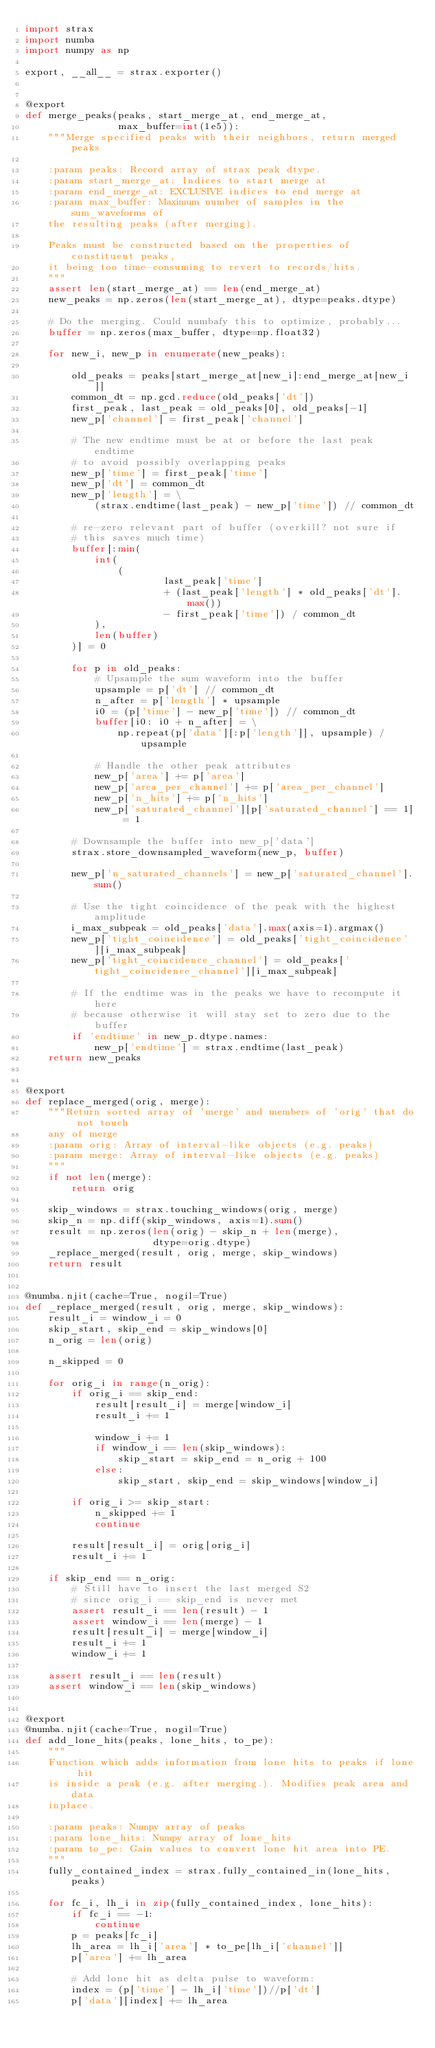Convert code to text. <code><loc_0><loc_0><loc_500><loc_500><_Python_>import strax
import numba
import numpy as np

export, __all__ = strax.exporter()


@export
def merge_peaks(peaks, start_merge_at, end_merge_at,
                max_buffer=int(1e5)):
    """Merge specified peaks with their neighbors, return merged peaks

    :param peaks: Record array of strax peak dtype.
    :param start_merge_at: Indices to start merge at
    :param end_merge_at: EXCLUSIVE indices to end merge at
    :param max_buffer: Maximum number of samples in the sum_waveforms of
    the resulting peaks (after merging).

    Peaks must be constructed based on the properties of constituent peaks,
    it being too time-consuming to revert to records/hits.
    """
    assert len(start_merge_at) == len(end_merge_at)
    new_peaks = np.zeros(len(start_merge_at), dtype=peaks.dtype)

    # Do the merging. Could numbafy this to optimize, probably...
    buffer = np.zeros(max_buffer, dtype=np.float32)

    for new_i, new_p in enumerate(new_peaks):

        old_peaks = peaks[start_merge_at[new_i]:end_merge_at[new_i]]
        common_dt = np.gcd.reduce(old_peaks['dt'])
        first_peak, last_peak = old_peaks[0], old_peaks[-1]
        new_p['channel'] = first_peak['channel']

        # The new endtime must be at or before the last peak endtime
        # to avoid possibly overlapping peaks
        new_p['time'] = first_peak['time']
        new_p['dt'] = common_dt
        new_p['length'] = \
            (strax.endtime(last_peak) - new_p['time']) // common_dt

        # re-zero relevant part of buffer (overkill? not sure if
        # this saves much time)
        buffer[:min(
            int(
                (
                        last_peak['time']
                        + (last_peak['length'] * old_peaks['dt'].max())
                        - first_peak['time']) / common_dt
            ),
            len(buffer)
        )] = 0

        for p in old_peaks:
            # Upsample the sum waveform into the buffer
            upsample = p['dt'] // common_dt
            n_after = p['length'] * upsample
            i0 = (p['time'] - new_p['time']) // common_dt
            buffer[i0: i0 + n_after] = \
                np.repeat(p['data'][:p['length']], upsample) / upsample

            # Handle the other peak attributes
            new_p['area'] += p['area']
            new_p['area_per_channel'] += p['area_per_channel']
            new_p['n_hits'] += p['n_hits']
            new_p['saturated_channel'][p['saturated_channel'] == 1] = 1

        # Downsample the buffer into new_p['data']
        strax.store_downsampled_waveform(new_p, buffer)

        new_p['n_saturated_channels'] = new_p['saturated_channel'].sum()

        # Use the tight coincidence of the peak with the highest amplitude
        i_max_subpeak = old_peaks['data'].max(axis=1).argmax()
        new_p['tight_coincidence'] = old_peaks['tight_coincidence'][i_max_subpeak]
        new_p['tight_coincidence_channel'] = old_peaks['tight_coincidence_channel'][i_max_subpeak]
        
        # If the endtime was in the peaks we have to recompute it here 
        # because otherwise it will stay set to zero due to the buffer
        if 'endtime' in new_p.dtype.names:
            new_p['endtime'] = strax.endtime(last_peak)
    return new_peaks


@export
def replace_merged(orig, merge):
    """Return sorted array of 'merge' and members of 'orig' that do not touch
    any of merge
    :param orig: Array of interval-like objects (e.g. peaks)
    :param merge: Array of interval-like objects (e.g. peaks)
    """
    if not len(merge):
        return orig

    skip_windows = strax.touching_windows(orig, merge)
    skip_n = np.diff(skip_windows, axis=1).sum()
    result = np.zeros(len(orig) - skip_n + len(merge),
                      dtype=orig.dtype)
    _replace_merged(result, orig, merge, skip_windows)
    return result


@numba.njit(cache=True, nogil=True)
def _replace_merged(result, orig, merge, skip_windows):
    result_i = window_i = 0
    skip_start, skip_end = skip_windows[0]
    n_orig = len(orig)

    n_skipped = 0

    for orig_i in range(n_orig):
        if orig_i == skip_end:
            result[result_i] = merge[window_i]
            result_i += 1

            window_i += 1
            if window_i == len(skip_windows):
                skip_start = skip_end = n_orig + 100
            else:
                skip_start, skip_end = skip_windows[window_i]

        if orig_i >= skip_start:
            n_skipped += 1
            continue

        result[result_i] = orig[orig_i]
        result_i += 1

    if skip_end == n_orig:
        # Still have to insert the last merged S2
        # since orig_i == skip_end is never met
        assert result_i == len(result) - 1
        assert window_i == len(merge) - 1
        result[result_i] = merge[window_i]
        result_i += 1
        window_i += 1

    assert result_i == len(result)
    assert window_i == len(skip_windows)

    
@export
@numba.njit(cache=True, nogil=True)
def add_lone_hits(peaks, lone_hits, to_pe):
    """
    Function which adds information from lone hits to peaks if lone hit
    is inside a peak (e.g. after merging.). Modifies peak area and data
    inplace.

    :param peaks: Numpy array of peaks
    :param lone_hits: Numpy array of lone_hits
    :param to_pe: Gain values to convert lone hit area into PE.
    """
    fully_contained_index = strax.fully_contained_in(lone_hits, peaks)

    for fc_i, lh_i in zip(fully_contained_index, lone_hits):
        if fc_i == -1:
            continue
        p = peaks[fc_i]
        lh_area = lh_i['area'] * to_pe[lh_i['channel']]
        p['area'] += lh_area

        # Add lone hit as delta pulse to waveform:
        index = (p['time'] - lh_i['time'])//p['dt']
        p['data'][index] += lh_area
</code> 